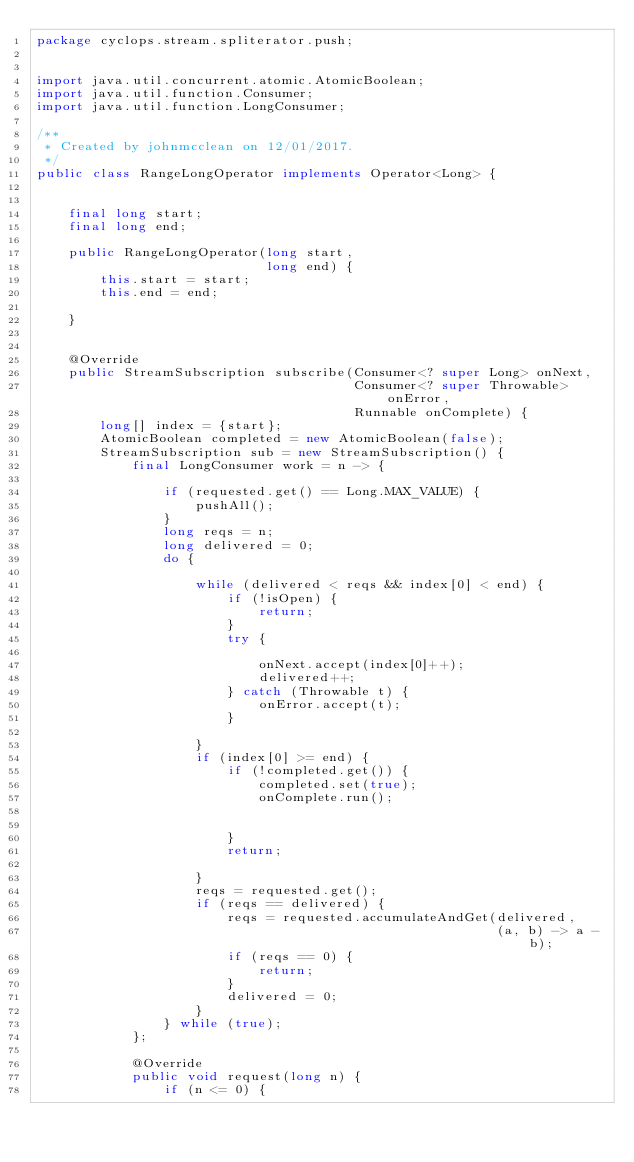Convert code to text. <code><loc_0><loc_0><loc_500><loc_500><_Java_>package cyclops.stream.spliterator.push;


import java.util.concurrent.atomic.AtomicBoolean;
import java.util.function.Consumer;
import java.util.function.LongConsumer;

/**
 * Created by johnmcclean on 12/01/2017.
 */
public class RangeLongOperator implements Operator<Long> {


    final long start;
    final long end;

    public RangeLongOperator(long start,
                             long end) {
        this.start = start;
        this.end = end;

    }


    @Override
    public StreamSubscription subscribe(Consumer<? super Long> onNext,
                                        Consumer<? super Throwable> onError,
                                        Runnable onComplete) {
        long[] index = {start};
        AtomicBoolean completed = new AtomicBoolean(false);
        StreamSubscription sub = new StreamSubscription() {
            final LongConsumer work = n -> {

                if (requested.get() == Long.MAX_VALUE) {
                    pushAll();
                }
                long reqs = n;
                long delivered = 0;
                do {

                    while (delivered < reqs && index[0] < end) {
                        if (!isOpen) {
                            return;
                        }
                        try {

                            onNext.accept(index[0]++);
                            delivered++;
                        } catch (Throwable t) {
                            onError.accept(t);
                        }

                    }
                    if (index[0] >= end) {
                        if (!completed.get()) {
                            completed.set(true);
                            onComplete.run();


                        }
                        return;

                    }
                    reqs = requested.get();
                    if (reqs == delivered) {
                        reqs = requested.accumulateAndGet(delivered,
                                                          (a, b) -> a - b);
                        if (reqs == 0) {
                            return;
                        }
                        delivered = 0;
                    }
                } while (true);
            };

            @Override
            public void request(long n) {
                if (n <= 0) {</code> 